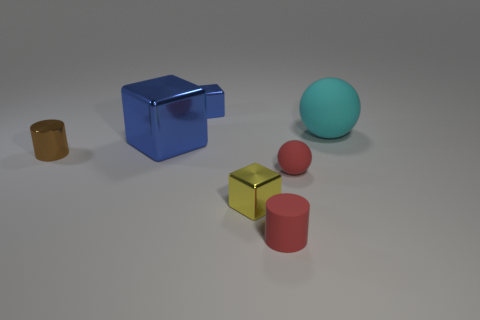Subtract all green blocks. Subtract all cyan cylinders. How many blocks are left? 3 Add 1 small brown shiny objects. How many objects exist? 8 Subtract all blocks. How many objects are left? 4 Subtract 1 red cylinders. How many objects are left? 6 Subtract all small red matte balls. Subtract all yellow metal things. How many objects are left? 5 Add 7 rubber balls. How many rubber balls are left? 9 Add 5 small brown objects. How many small brown objects exist? 6 